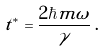Convert formula to latex. <formula><loc_0><loc_0><loc_500><loc_500>t ^ { * } = \frac { 2 \hbar { m } \omega } { \gamma } \, .</formula> 